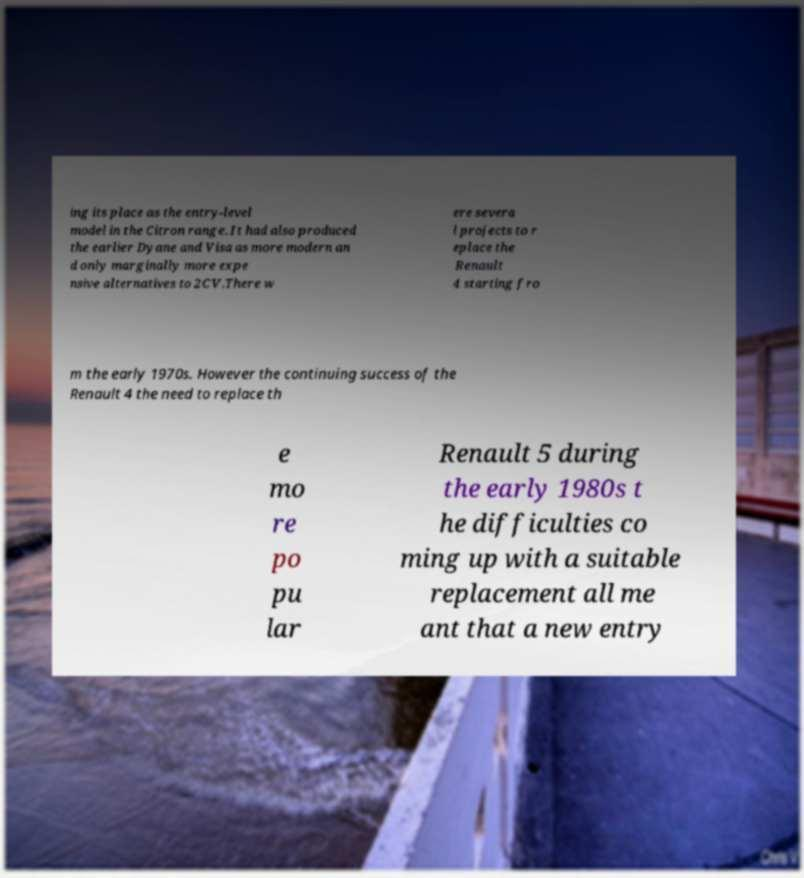Could you extract and type out the text from this image? ing its place as the entry-level model in the Citron range. It had also produced the earlier Dyane and Visa as more modern an d only marginally more expe nsive alternatives to 2CV.There w ere severa l projects to r eplace the Renault 4 starting fro m the early 1970s. However the continuing success of the Renault 4 the need to replace th e mo re po pu lar Renault 5 during the early 1980s t he difficulties co ming up with a suitable replacement all me ant that a new entry 